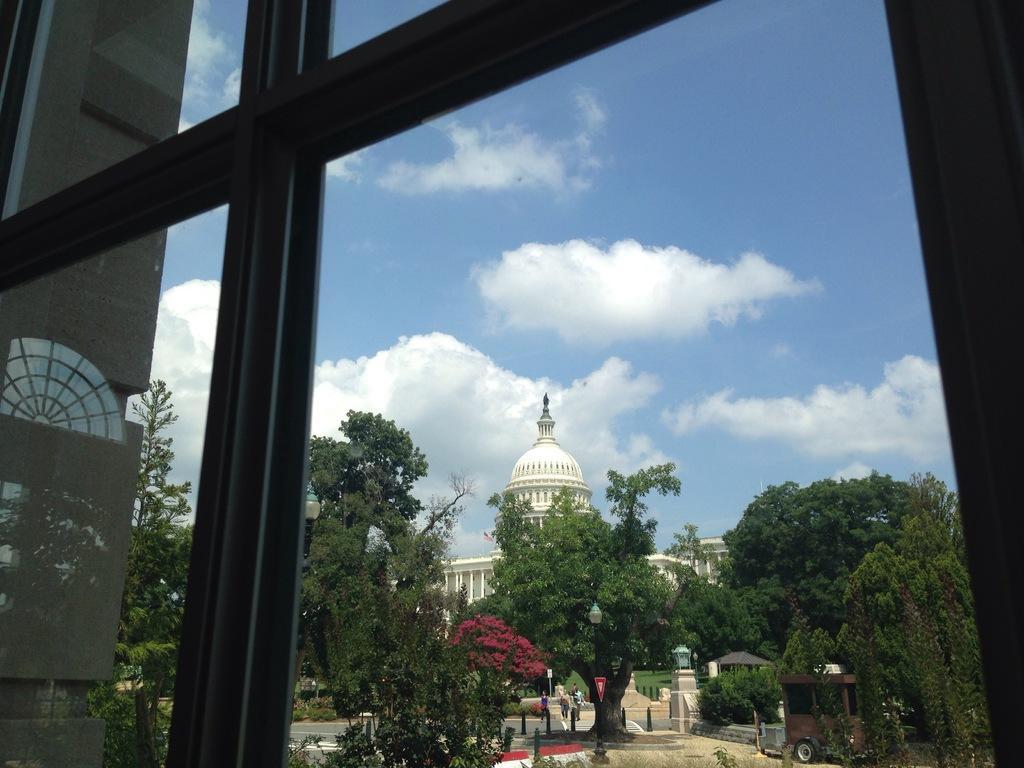Please provide a concise description of this image. In this picture there is a glass window, through the window I can see the building , trees and the sky with clouds. 